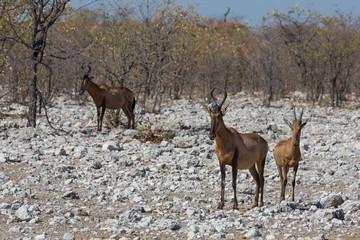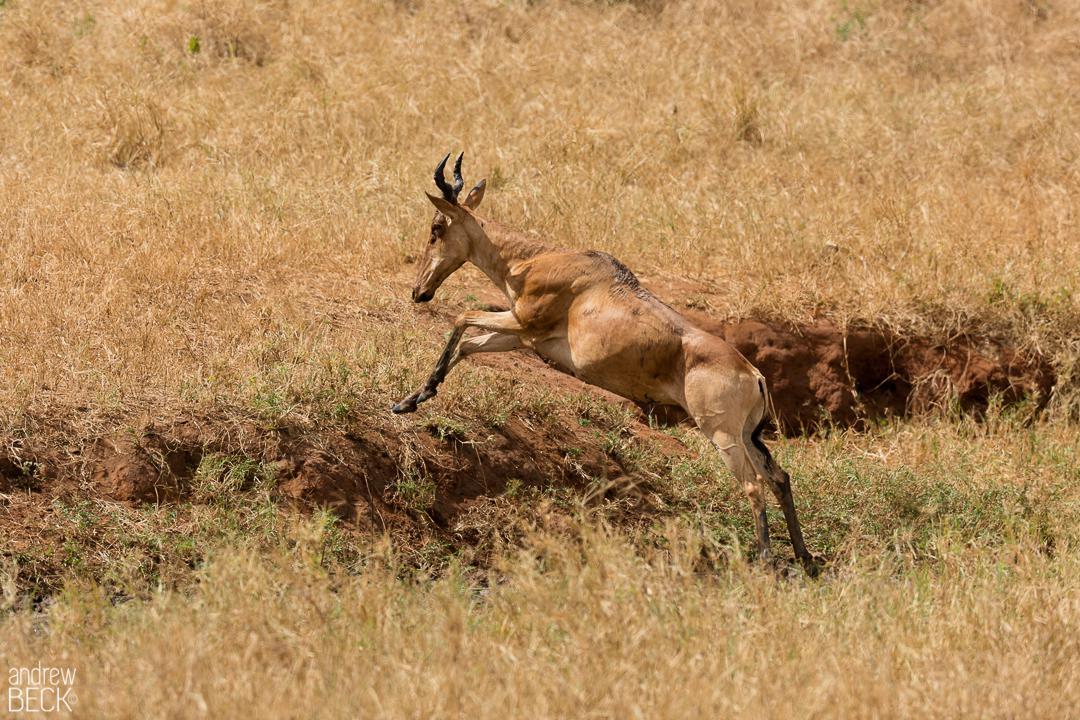The first image is the image on the left, the second image is the image on the right. Evaluate the accuracy of this statement regarding the images: "At least one antelope has its front legs int he air.". Is it true? Answer yes or no. Yes. The first image is the image on the left, the second image is the image on the right. Examine the images to the left and right. Is the description "An image includes a horned animal that is bounding with front legs fully off the ground." accurate? Answer yes or no. Yes. 